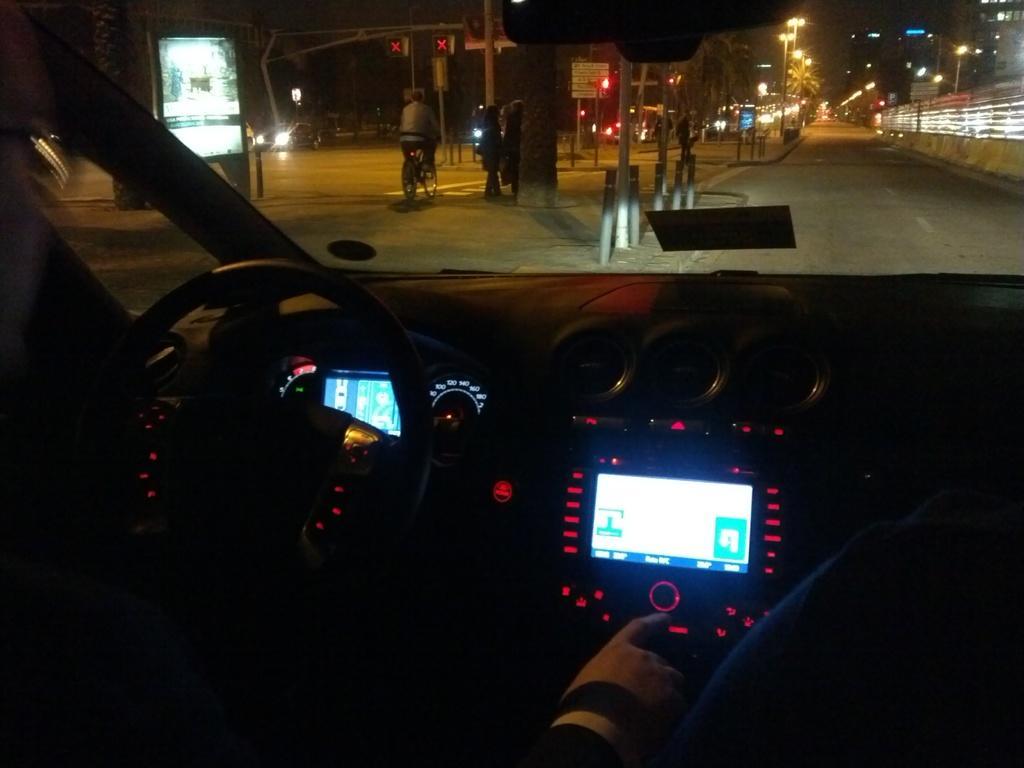In one or two sentences, can you explain what this image depicts? In this picture we can see inside of the vehicle. We can see hand of person's, steering wheel, screens and windshield, through this windshield we can see people, poles, lights, boards, road, fence, buildings and trees. 